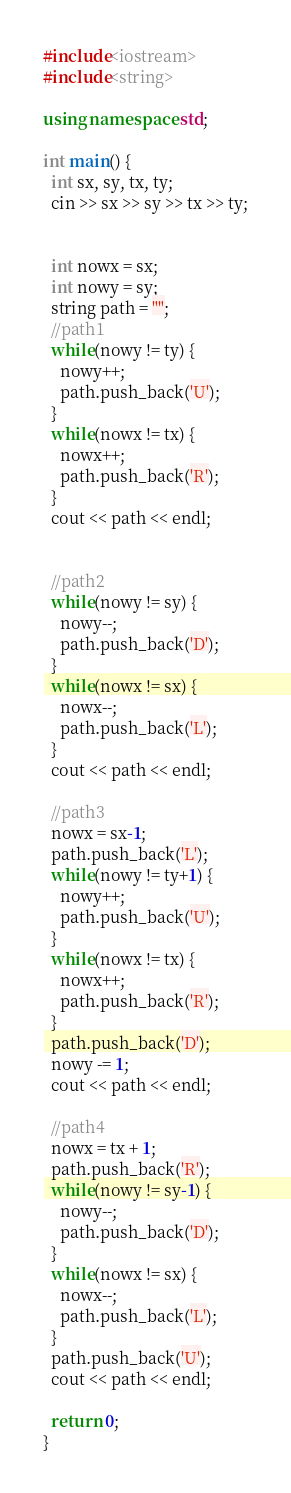<code> <loc_0><loc_0><loc_500><loc_500><_C++_>#include<iostream>
#include<string>

using namespace std;

int main() {
  int sx, sy, tx, ty;
  cin >> sx >> sy >> tx >> ty;


  int nowx = sx;
  int nowy = sy;
  string path = "";
  //path1
  while(nowy != ty) {
    nowy++;
    path.push_back('U');
  }
  while(nowx != tx) {
    nowx++;
    path.push_back('R');
  }
  cout << path << endl;


  //path2
  while(nowy != sy) {
    nowy--;
    path.push_back('D');
  }
  while(nowx != sx) {
    nowx--;
    path.push_back('L');
  }
  cout << path << endl;

  //path3
  nowx = sx-1;
  path.push_back('L');
  while(nowy != ty+1) {
    nowy++;
    path.push_back('U');
  }
  while(nowx != tx) {
    nowx++;
    path.push_back('R');
  }
  path.push_back('D');
  nowy -= 1;
  cout << path << endl;

  //path4
  nowx = tx + 1;
  path.push_back('R');
  while(nowy != sy-1) {
    nowy--;
    path.push_back('D');
  }
  while(nowx != sx) {
    nowx--;
    path.push_back('L');
  }
  path.push_back('U');
  cout << path << endl;

  return 0;
}
</code> 